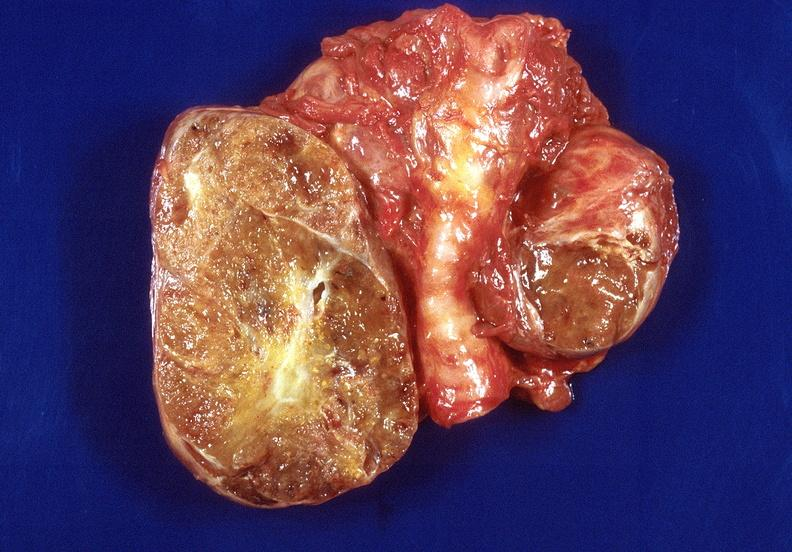what is present?
Answer the question using a single word or phrase. Endocrine 